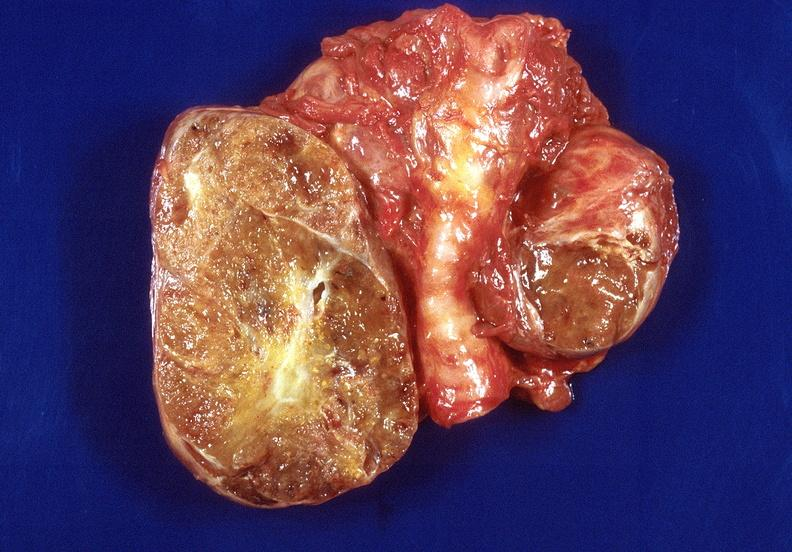what is present?
Answer the question using a single word or phrase. Endocrine 